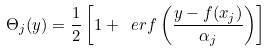Convert formula to latex. <formula><loc_0><loc_0><loc_500><loc_500>\Theta _ { j } ( y ) = \frac { 1 } { 2 } \left [ 1 + \ e r f \left ( \frac { y - f ( x _ { j } ) } { \alpha _ { j } } \right ) \right ]</formula> 